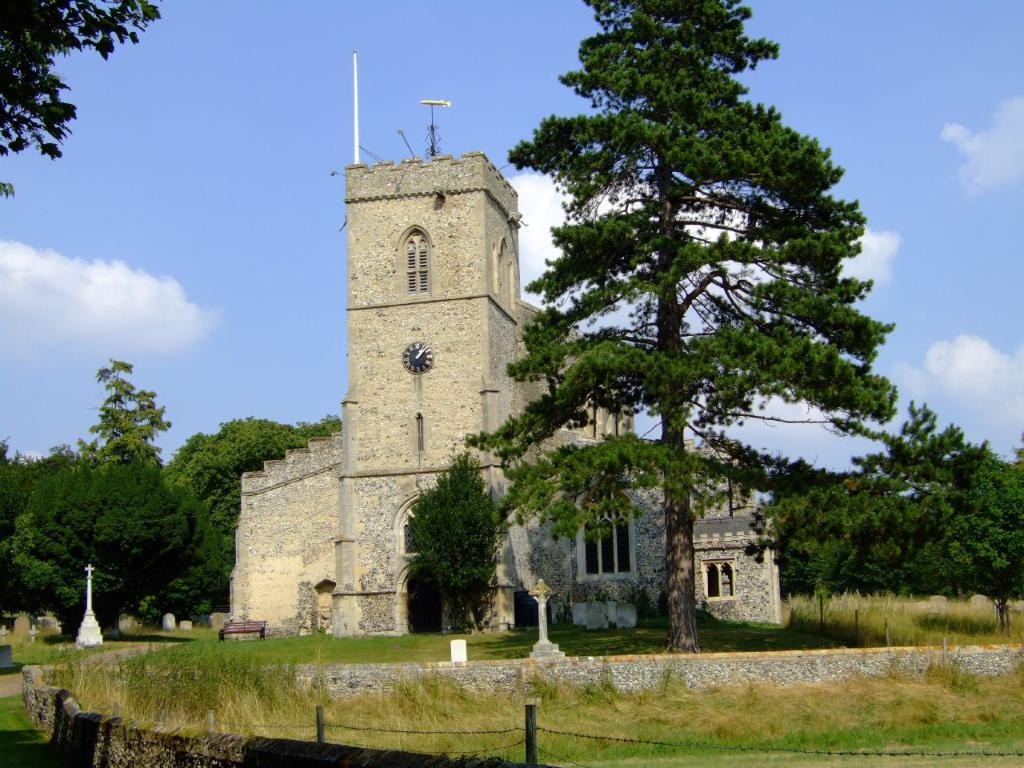What type of structure can be seen in the image? There is a stone building in the image. What is the color of the sky in the background? The sky is blue in the background. What type of vegetation is present in the image? There are trees in the image. What type of seating is available in the image? There is a wooden bench in the image. What other features can be seen in the image? There is a wall, a fence, and grass visible in the image. How many eyes can be seen on the shop in the image? There is no shop present in the image, so it is not possible to determine the number of eyes on a shop. 